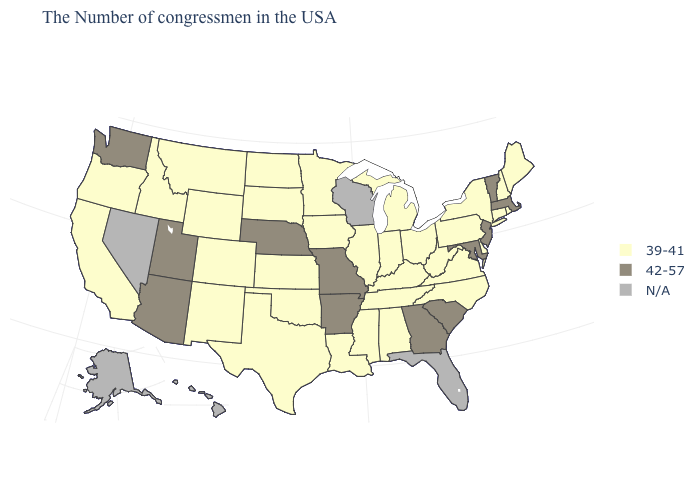Among the states that border New Hampshire , which have the highest value?
Concise answer only. Massachusetts, Vermont. What is the value of California?
Keep it brief. 39-41. Name the states that have a value in the range 39-41?
Concise answer only. Maine, Rhode Island, New Hampshire, Connecticut, New York, Delaware, Pennsylvania, Virginia, North Carolina, West Virginia, Ohio, Michigan, Kentucky, Indiana, Alabama, Tennessee, Illinois, Mississippi, Louisiana, Minnesota, Iowa, Kansas, Oklahoma, Texas, South Dakota, North Dakota, Wyoming, Colorado, New Mexico, Montana, Idaho, California, Oregon. Name the states that have a value in the range 39-41?
Answer briefly. Maine, Rhode Island, New Hampshire, Connecticut, New York, Delaware, Pennsylvania, Virginia, North Carolina, West Virginia, Ohio, Michigan, Kentucky, Indiana, Alabama, Tennessee, Illinois, Mississippi, Louisiana, Minnesota, Iowa, Kansas, Oklahoma, Texas, South Dakota, North Dakota, Wyoming, Colorado, New Mexico, Montana, Idaho, California, Oregon. Name the states that have a value in the range N/A?
Keep it brief. Florida, Wisconsin, Nevada, Alaska, Hawaii. What is the lowest value in states that border North Dakota?
Give a very brief answer. 39-41. What is the value of Maine?
Short answer required. 39-41. Does the first symbol in the legend represent the smallest category?
Answer briefly. Yes. Does Idaho have the highest value in the USA?
Be succinct. No. Name the states that have a value in the range 39-41?
Keep it brief. Maine, Rhode Island, New Hampshire, Connecticut, New York, Delaware, Pennsylvania, Virginia, North Carolina, West Virginia, Ohio, Michigan, Kentucky, Indiana, Alabama, Tennessee, Illinois, Mississippi, Louisiana, Minnesota, Iowa, Kansas, Oklahoma, Texas, South Dakota, North Dakota, Wyoming, Colorado, New Mexico, Montana, Idaho, California, Oregon. What is the value of Wyoming?
Be succinct. 39-41. What is the value of Kentucky?
Write a very short answer. 39-41. What is the value of Texas?
Short answer required. 39-41. Name the states that have a value in the range N/A?
Write a very short answer. Florida, Wisconsin, Nevada, Alaska, Hawaii. Name the states that have a value in the range 39-41?
Keep it brief. Maine, Rhode Island, New Hampshire, Connecticut, New York, Delaware, Pennsylvania, Virginia, North Carolina, West Virginia, Ohio, Michigan, Kentucky, Indiana, Alabama, Tennessee, Illinois, Mississippi, Louisiana, Minnesota, Iowa, Kansas, Oklahoma, Texas, South Dakota, North Dakota, Wyoming, Colorado, New Mexico, Montana, Idaho, California, Oregon. 